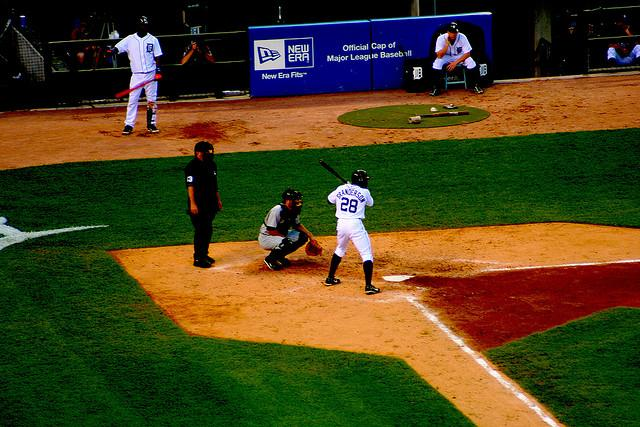The person wearing what color of shirt officiates the game? Please explain your reasoning. black. The color of the clothes indicates the person is a neutral third party. 